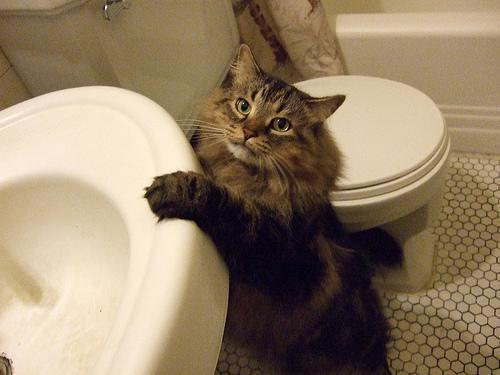How many paws of the cat on the sink?
Give a very brief answer. 1. 